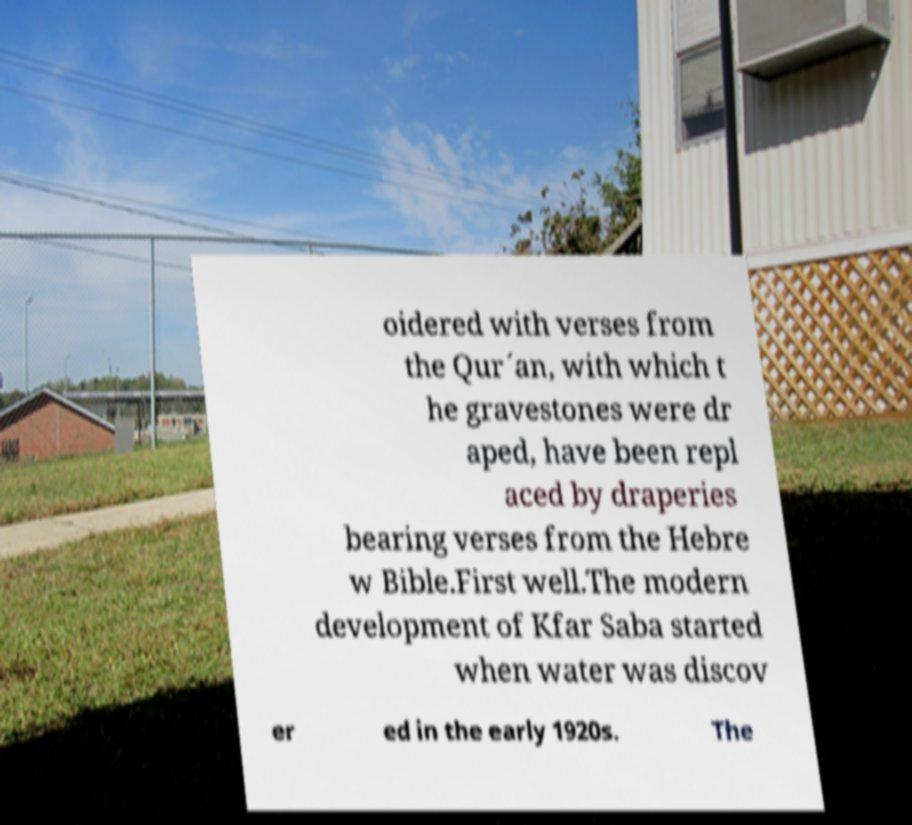There's text embedded in this image that I need extracted. Can you transcribe it verbatim? oidered with verses from the Qur´an, with which t he gravestones were dr aped, have been repl aced by draperies bearing verses from the Hebre w Bible.First well.The modern development of Kfar Saba started when water was discov er ed in the early 1920s. The 